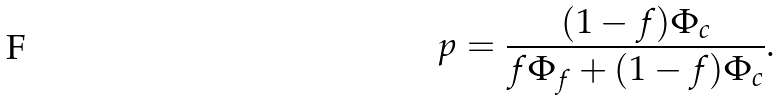<formula> <loc_0><loc_0><loc_500><loc_500>p = \frac { ( 1 - f ) \Phi _ { c } } { f \Phi _ { f } + ( 1 - f ) \Phi _ { c } } .</formula> 